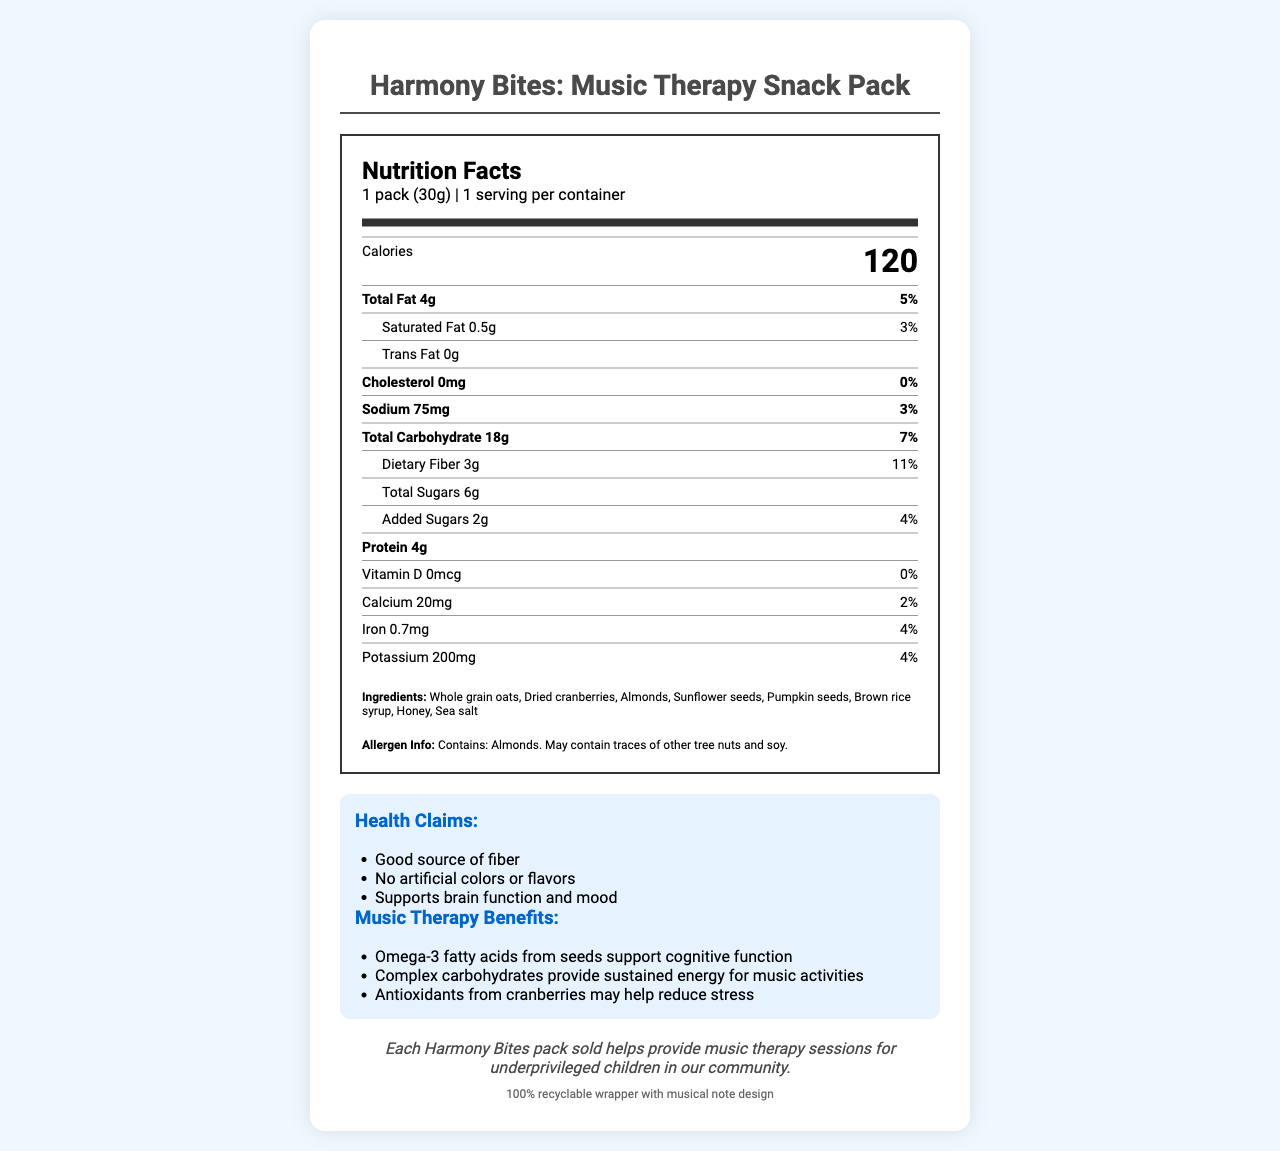what is the serving size of the Harmony Bites pack? The serving size is indicated as "1 pack (30g)" under the serving information section.
Answer: 1 pack (30g) how many calories are in one serving of the Harmony Bites pack? The calorie content is detailed prominently under the nutrition facts with a larger font.
Answer: 120 calories what is the total fat content and its daily value percentage in the Harmony Bites pack? The total fat content is listed as "4g" and the daily value percentage as "5%" under the main nutrients section.
Answer: 4g, 5% how much dietary fiber does the Harmony Bites pack contain? The amount of dietary fiber is listed as "3g" in the nutrient breakdown with an 11% daily value.
Answer: 3g which ingredient in the Harmony Bites pack highlights the inclusion of tree nuts? Under ingredients, "Almonds" is listed, and the allergen information also states "Contains: Almonds."
Answer: Almonds what are the music therapy benefits mentioned for Harmony Bites? (Select all that apply) 1. Supports cognitive function 2. Increases physical strength 3. Provides sustained energy 4. Reduces stress The document lists "Omega-3 fatty acids from seeds support cognitive function," "Complex carbohydrates provide sustained energy for music activities," and "Antioxidants from cranberries may help reduce stress."
Answer: 1, 3, 4 how many servings per container are there in the Harmony Bites pack? The serving info section indicates "1 serving per container."
Answer: 1 which nutrient has no amount added in the Harmony Bites pack? A. Cholesterol B. Vitamin D C. Iron D. Trans Fat The document shows "Trans Fat" as 0g under the sub-nutrient section.
Answer: D does the Harmony Bites pack contain any added sugars? The document lists "Added Sugars" as "2g" with a daily value of "4%."
Answer: Yes describe the main focus of the document. The document is designed to give a comprehensive view of the nutritional value of Harmony Bites, emphasizing its benefits for music therapy, health, and the environment.
Answer: The document provides the nutrition facts for the Harmony Bites: Music Therapy Snack Pack. It highlights the serving size, calorie content, nutrient details, and ingredients along with health claims, music therapy benefits, allergen information, and the charity impact statement. The packaging is also noted as 100% recyclable. how much potassium is in the Harmony Bites pack based on daily value percentage? The daily value percentage for potassium is listed as 4% in the nutrient section.
Answer: 4% which component of Harmony Bites supports brain function and mood according to the health claims? A. Fiber B. Protein C. Omega-3 fatty acids D. Iron The health claims mention "supports brain function and mood," and the music therapy benefits specify "Omega-3 fatty acids from seeds support cognitive function."
Answer: C what is the most notable allergen present in Harmony Bites? The allergen info states "Contains: Almonds."
Answer: Almonds what is the amount of protein in one serving of Harmony Bites? The amount of protein is listed as "4g" in the nutrient breakdown.
Answer: 4g how many milligrams of calcium does one serving of Harmony Bites contain? Under the nutrient section, the document lists calcium as "20mg."
Answer: 20mg where do the funds from each Harmony Bites pack sold go? The charity impact statement mentions that each pack sold helps provide music therapy sessions for underprivileged children in the community.
Answer: Provide music therapy sessions for underprivileged children what percentage of daily sodium intake does a Harmony Bites pack provide? The nutrient breakdown lists the sodium content with a daily value of 3%.
Answer: 3% what is the impact of antioxidants from cranberries in the Harmony Bites pack according to the document? The music therapy benefits section states that antioxidants from cranberries may help reduce stress.
Answer: May help reduce stress explain the intended environmental impact of the Harmony Bites packaging. The packaging info at the end of the document notes that the wrapper is 100% recyclable.
Answer: The packaging is intended to be environmentally friendly since it is 100% recyclable. how do the complex carbohydrates in Harmony Bites benefit children during music therapy sessions? The music therapy benefits mention that complex carbohydrates provide sustained energy, which is beneficial for music activities.
Answer: Provide sustained energy for music activities what is the amount of sugar added to the Harmony Bites pack? Under the nutrient section, added sugars amount to 2g.
Answer: 2g are omega-3 fatty acids directly listed in the ingredients of Harmony Bites? The document does not explicitly list omega-3 fatty acids in the ingredients section; it only mentions their benefits in the music therapy section.
Answer: Not enough information 